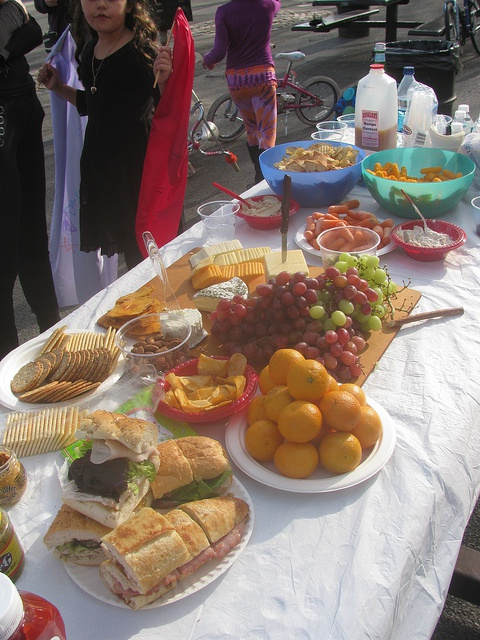Describe the objects in this image and their specific colors. I can see dining table in maroon, lightgray, darkgray, gray, and brown tones, people in maroon, black, and brown tones, sandwich in maroon, gray, and tan tones, people in maroon, black, gray, and lightgray tones, and orange in maroon, brown, and orange tones in this image. 